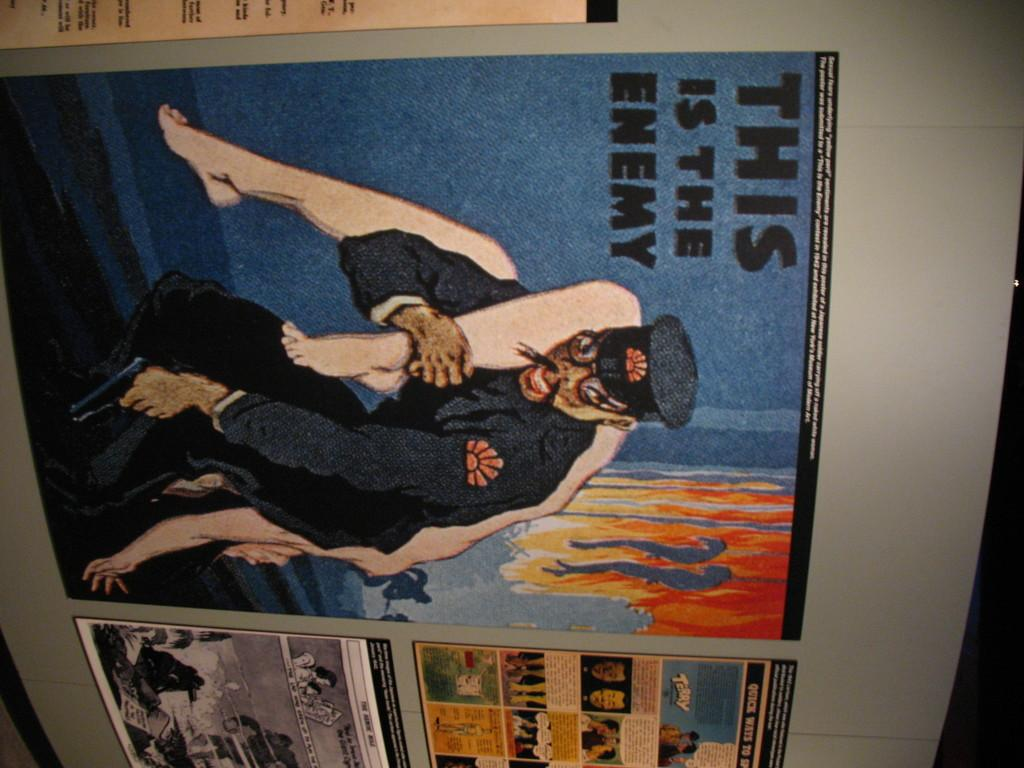<image>
Give a short and clear explanation of the subsequent image. An illustration shows a man carrying a body and the text This is the Enemy. 